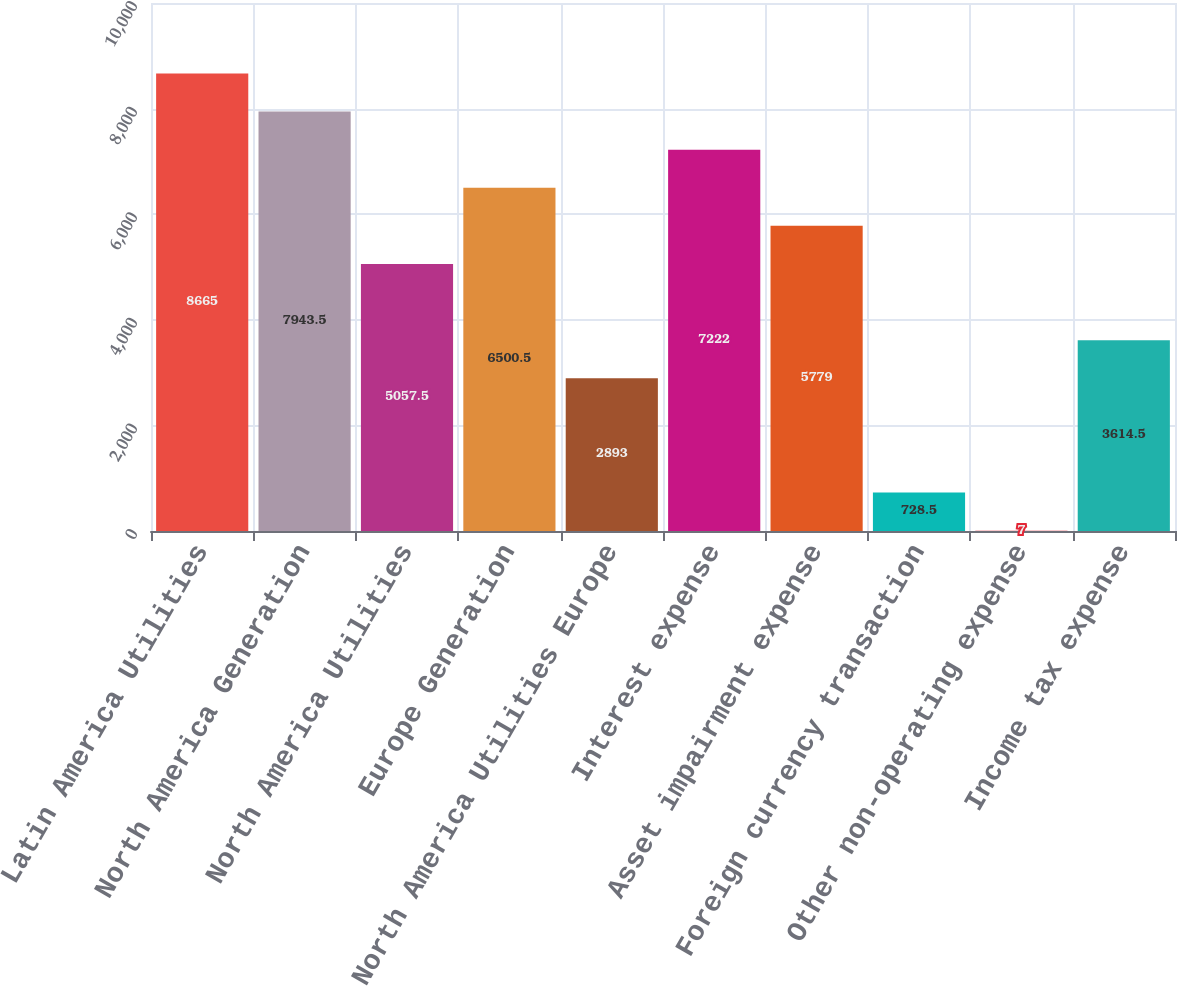Convert chart. <chart><loc_0><loc_0><loc_500><loc_500><bar_chart><fcel>Latin America Utilities<fcel>North America Generation<fcel>North America Utilities<fcel>Europe Generation<fcel>North America Utilities Europe<fcel>Interest expense<fcel>Asset impairment expense<fcel>Foreign currency transaction<fcel>Other non-operating expense<fcel>Income tax expense<nl><fcel>8665<fcel>7943.5<fcel>5057.5<fcel>6500.5<fcel>2893<fcel>7222<fcel>5779<fcel>728.5<fcel>7<fcel>3614.5<nl></chart> 